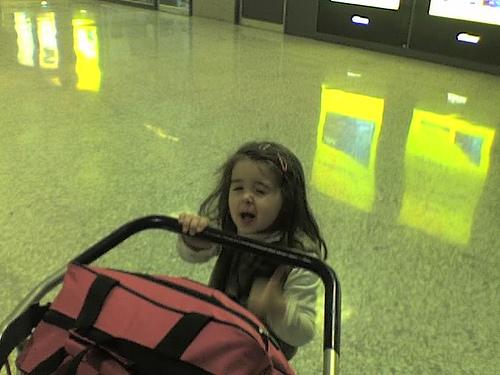Is the floor shiny?
Answer briefly. Yes. Where is the little girl?
Quick response, please. Airport. Is the flooring marble?
Answer briefly. Yes. 